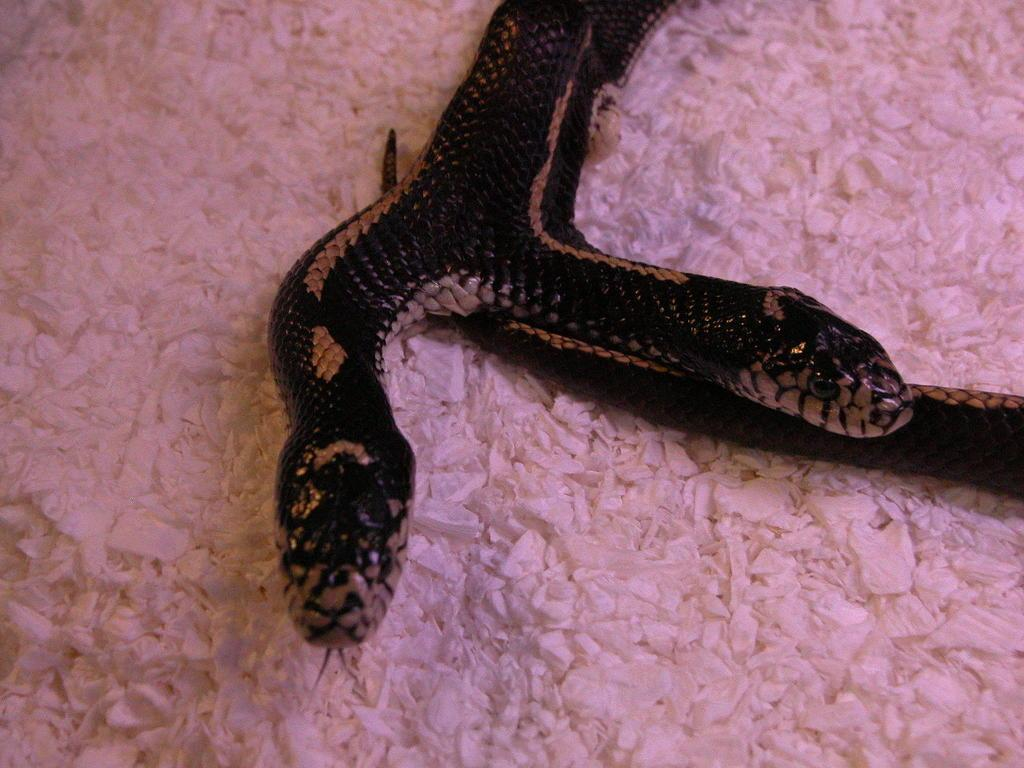What animal is present in the image? There is a snake in the picture. Does the snake have any unique features? Yes, the snake has two heads. What is the color of the snake? The snake is black in color. What is the snake resting on in the image? The snake is on a pink surface. What type of popcorn is being served in the image? There is no popcorn present in the image; it features a two-headed black snake on a pink surface. Can you see a horn on the snake's head in the image? There is no horn visible on the snake's head in the image. 